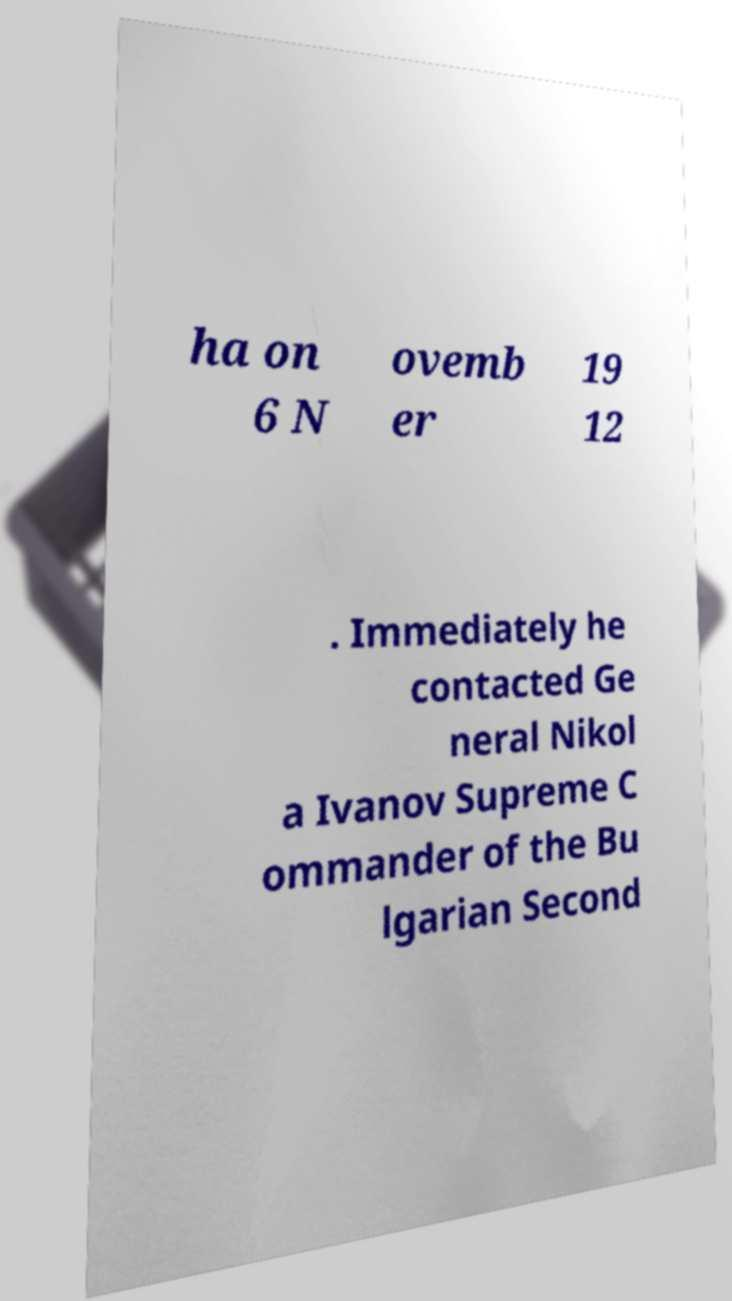What messages or text are displayed in this image? I need them in a readable, typed format. ha on 6 N ovemb er 19 12 . Immediately he contacted Ge neral Nikol a Ivanov Supreme C ommander of the Bu lgarian Second 